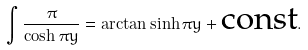<formula> <loc_0><loc_0><loc_500><loc_500>\int \frac { \pi } { \cosh \pi y } = \arctan \sinh \pi y + \text {const} .</formula> 